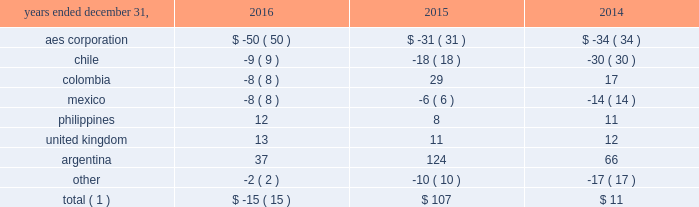The net decrease in the 2016 effective tax rate was due , in part , to the 2016 asset impairments in the u.s .
And to the current year benefit related to a restructuring of one of our brazilian businesses that increases tax basis in long-term assets .
Further , the 2015 rate was impacted by the items described below .
See note 20 2014asset impairment expense for additional information regarding the 2016 u.s .
Asset impairments .
Income tax expense increased $ 101 million , or 27% ( 27 % ) , to $ 472 million in 2015 .
The company's effective tax rates were 41% ( 41 % ) and 26% ( 26 % ) for the years ended december 31 , 2015 and 2014 , respectively .
The net increase in the 2015 effective tax rate was due , in part , to the nondeductible 2015 impairment of goodwill at our u.s .
Utility , dp&l and chilean withholding taxes offset by the release of valuation allowance at certain of our businesses in brazil , vietnam and the u.s .
Further , the 2014 rate was impacted by the sale of approximately 45% ( 45 % ) of the company 2019s interest in masin aes pte ltd. , which owns the company 2019s business interests in the philippines and the 2014 sale of the company 2019s interests in four u.k .
Wind operating projects .
Neither of these transactions gave rise to income tax expense .
See note 15 2014equity for additional information regarding the sale of approximately 45% ( 45 % ) of the company 2019s interest in masin-aes pte ltd .
See note 23 2014dispositions for additional information regarding the sale of the company 2019s interests in four u.k .
Wind operating projects .
Our effective tax rate reflects the tax effect of significant operations outside the u.s. , which are generally taxed at rates lower than the u.s .
Statutory rate of 35% ( 35 % ) .
A future proportionate change in the composition of income before income taxes from foreign and domestic tax jurisdictions could impact our periodic effective tax rate .
The company also benefits from reduced tax rates in certain countries as a result of satisfying specific commitments regarding employment and capital investment .
See note 21 2014income taxes for additional information regarding these reduced rates .
Foreign currency transaction gains ( losses ) foreign currency transaction gains ( losses ) in millions were as follows: .
Total ( 1 ) $ ( 15 ) $ 107 $ 11 _____________________________ ( 1 ) includes gains of $ 17 million , $ 247 million and $ 172 million on foreign currency derivative contracts for the years ended december 31 , 2016 , 2015 and 2014 , respectively .
The company recognized a net foreign currency transaction loss of $ 15 million for the year ended december 31 , 2016 primarily due to losses of $ 50 million at the aes corporation mainly due to remeasurement losses on intercompany notes , and losses on swaps and options .
This loss was partially offset by gains of $ 37 million in argentina , mainly due to the favorable impact of foreign currency derivatives related to government receivables .
The company recognized a net foreign currency transaction gain of $ 107 million for the year ended december 31 , 2015 primarily due to gains of : 2022 $ 124 million in argentina , due to the favorable impact from foreign currency derivatives related to government receivables , partially offset by losses from the devaluation of the argentine peso associated with u.s .
Dollar denominated debt , and losses at termoandes ( a u.s .
Dollar functional currency subsidiary ) primarily associated with cash and accounts receivable balances in local currency , 2022 $ 29 million in colombia , mainly due to the depreciation of the colombian peso , positively impacting chivor ( a u.s .
Dollar functional currency subsidiary ) due to liabilities denominated in colombian pesos , 2022 $ 11 million in the united kingdom , mainly due to the depreciation of the pound sterling , resulting in gains at ballylumford holdings ( a u.s .
Dollar functional currency subsidiary ) associated with intercompany notes payable denominated in pound sterling , and .
What was the change in millions between 2014 and 2015 of foreign currency transaction gains ( losses ) for aes corporation? 
Computations: (-31 - -34)
Answer: 3.0. 